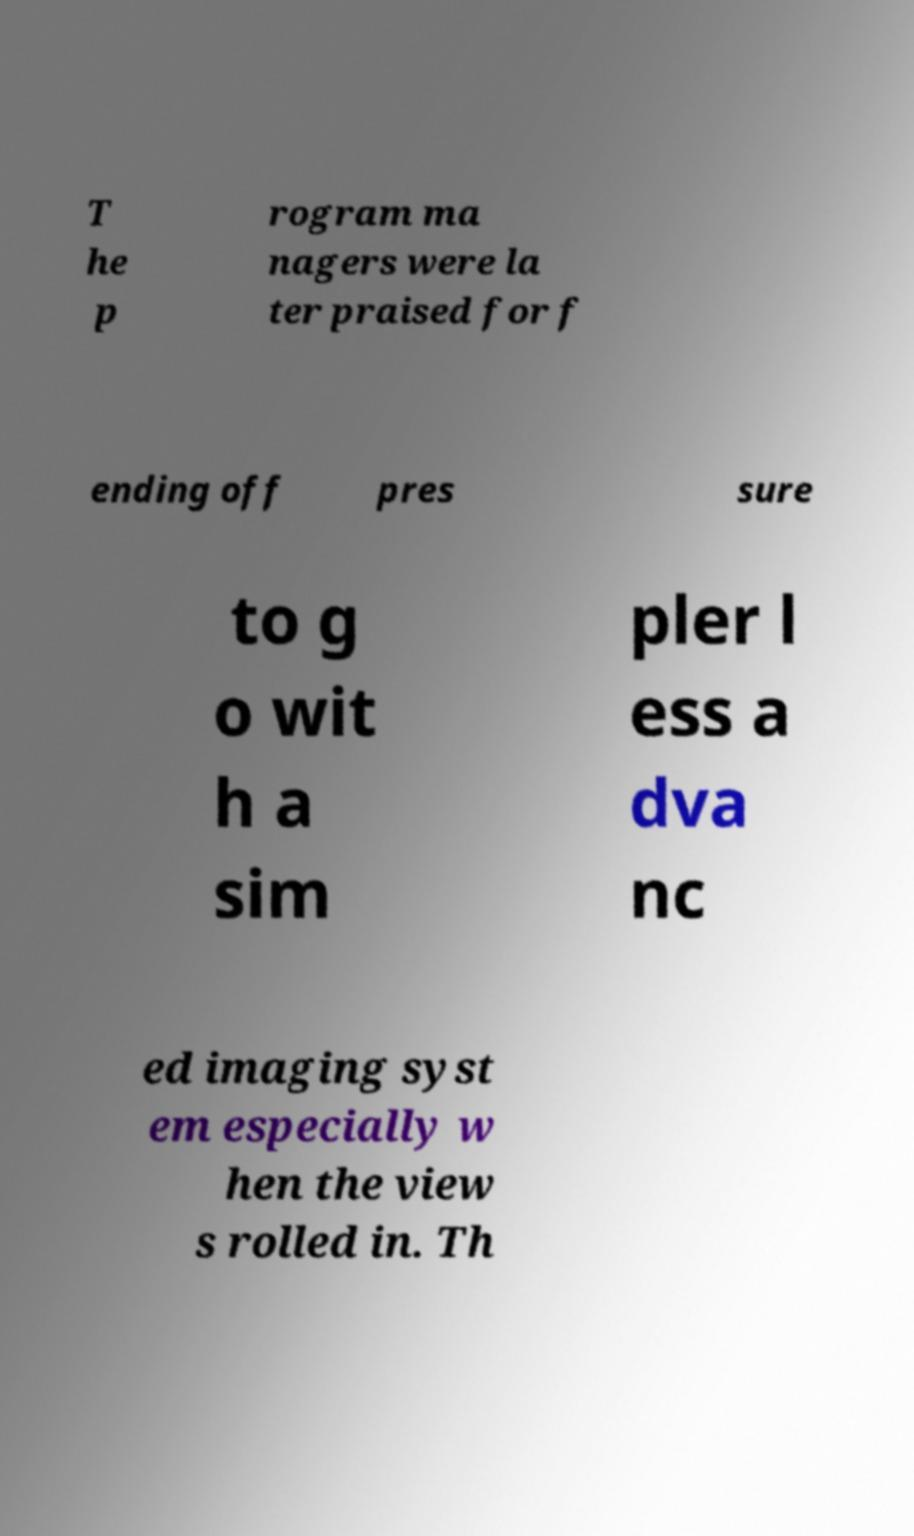What messages or text are displayed in this image? I need them in a readable, typed format. T he p rogram ma nagers were la ter praised for f ending off pres sure to g o wit h a sim pler l ess a dva nc ed imaging syst em especially w hen the view s rolled in. Th 